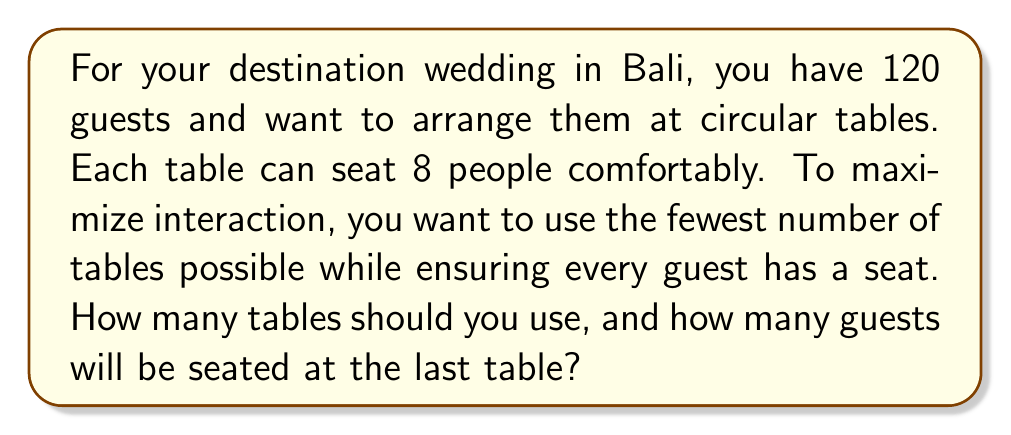Provide a solution to this math problem. To solve this problem, we need to follow these steps:

1) Calculate the number of full tables:
   Let $x$ be the number of full tables.
   $$x = \lfloor \frac{120}{8} \rfloor = 15$$
   Where $\lfloor \rfloor$ represents the floor function.

2) Calculate the number of guests seated at full tables:
   $$15 \times 8 = 120$$

3) Calculate the remaining guests:
   $$120 - 120 = 0$$

4) Determine if an additional table is needed:
   Since there are no remaining guests, no additional table is needed.

5) Calculate the number of guests at the last table:
   The last table will be full, so it will seat 8 guests.

Therefore, you should use 15 tables, and the last table will have 8 guests.
Answer: 15 tables; 8 guests at the last table 